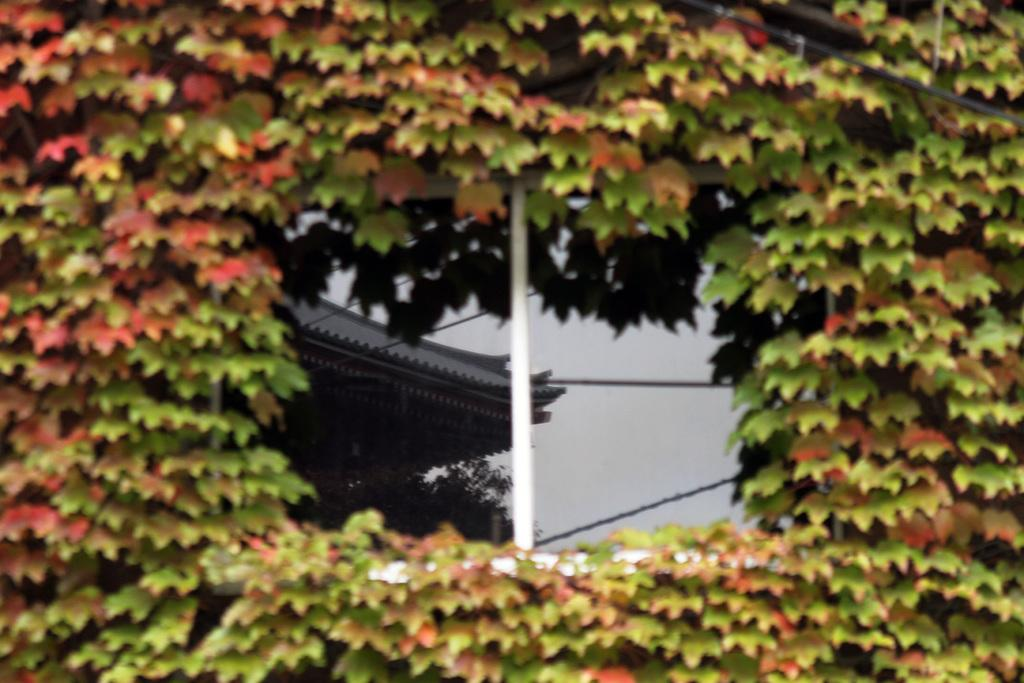What is located in the foreground of the image? There are plants in the foreground of the image. What is in the center of the image? There is a window in the center of the image. What can be seen as a reflection in the window? Trees and wires are visible as a reflection in the window. Where is the goose located in the image? There is no goose present in the image. What type of sack is being used to carry the plants in the foreground? There is no sack visible in the image, and the plants are not being carried. 